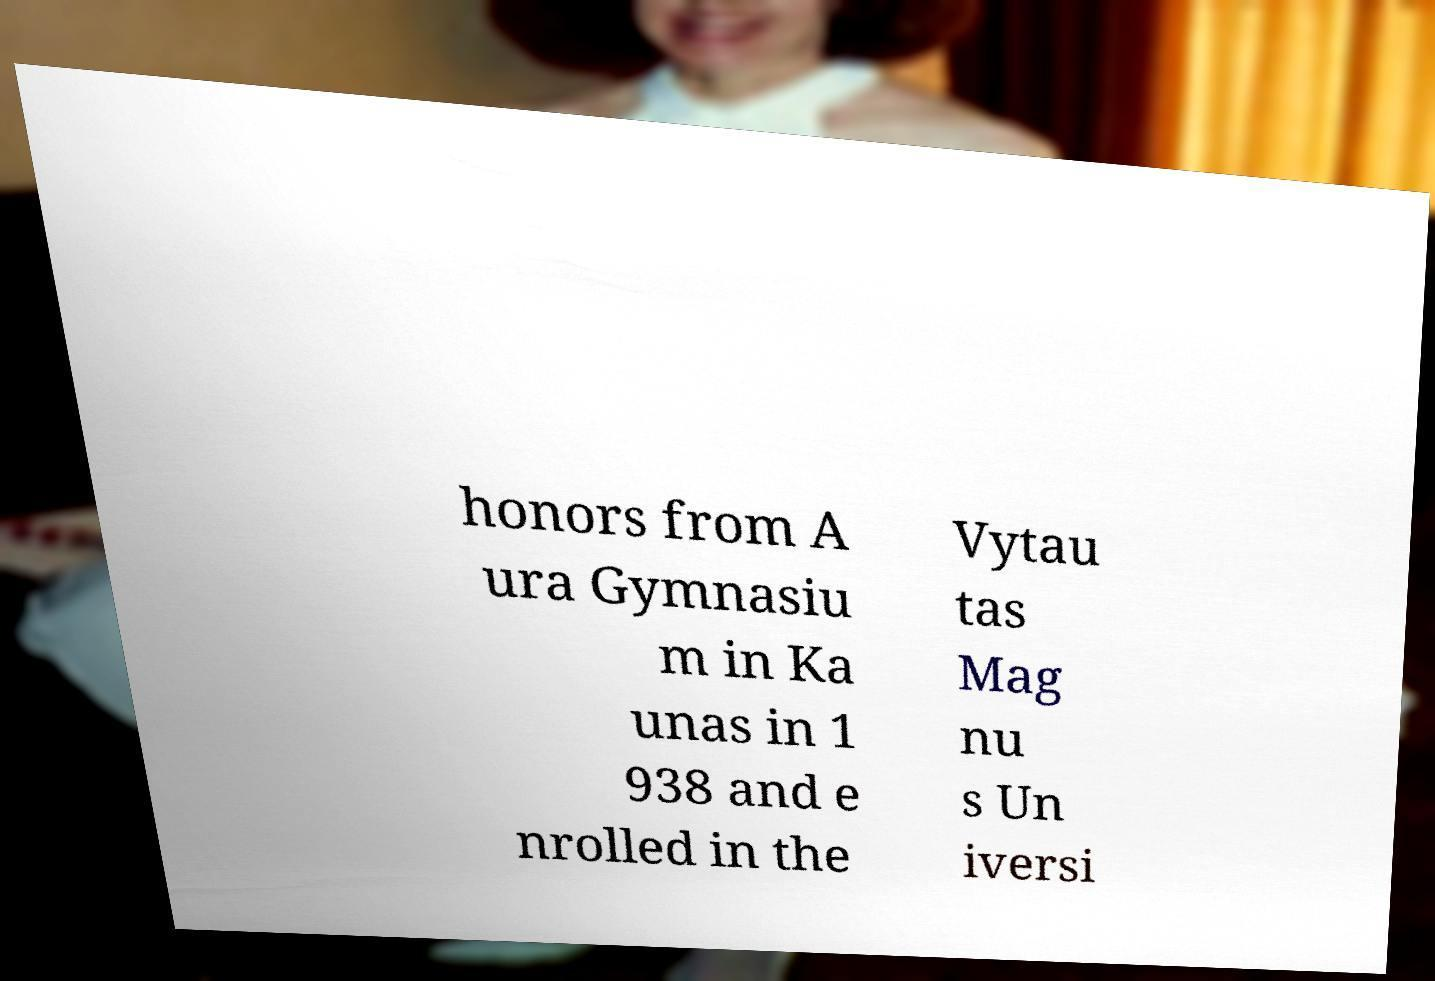Please identify and transcribe the text found in this image. honors from A ura Gymnasiu m in Ka unas in 1 938 and e nrolled in the Vytau tas Mag nu s Un iversi 